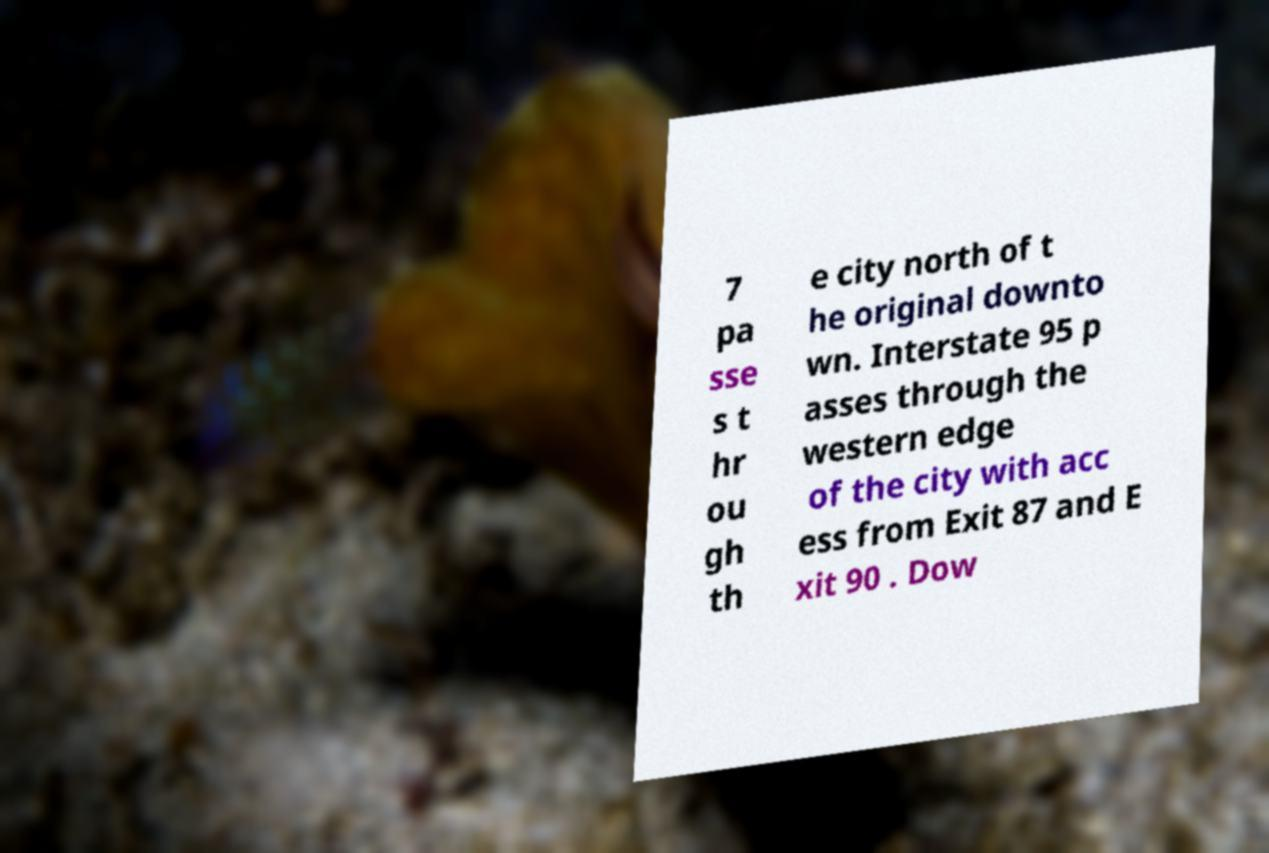What messages or text are displayed in this image? I need them in a readable, typed format. 7 pa sse s t hr ou gh th e city north of t he original downto wn. Interstate 95 p asses through the western edge of the city with acc ess from Exit 87 and E xit 90 . Dow 